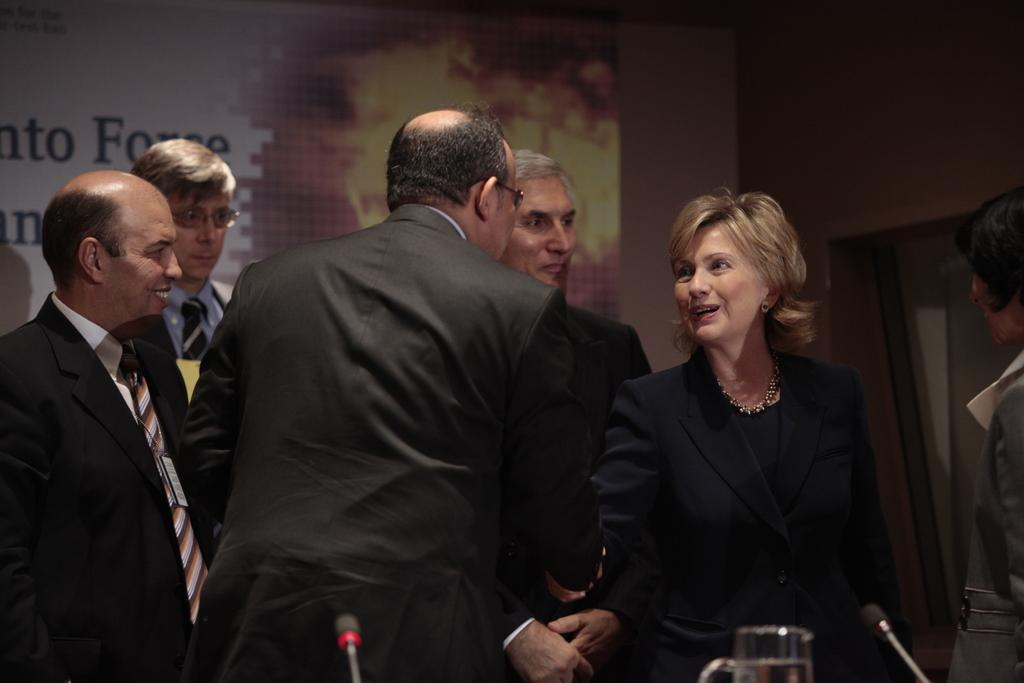How many people are in the image? There is a group of people in the image. What are two people in the image doing? Two people are greeting each other in the image. What can be seen in the background of the image? There is a banner in the background of the image, and a wall beside the banner. What type of vein is visible on the drum in the image? There is no drum or vein present in the image. What material is the plastic used for in the image? There is no plastic present in the image. 